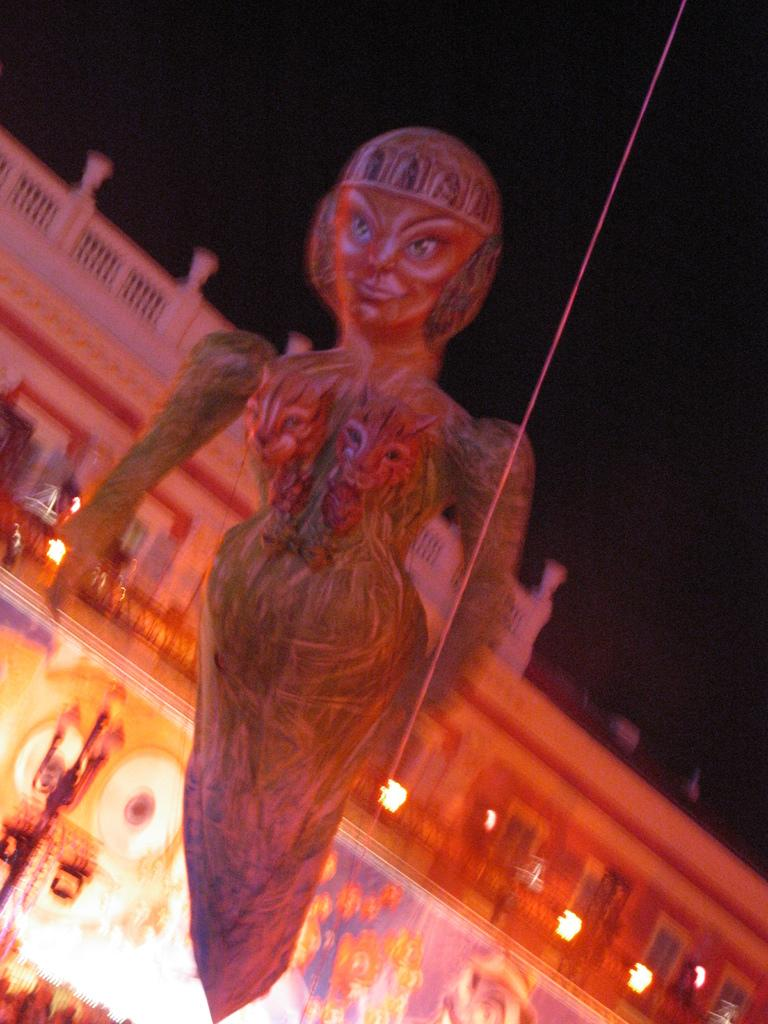What is the main subject in the center of the image? There is a doll in the center of the image. How are the walls of the house depicted in the image? The house has painted walls. Can you describe the object located in the bottom left corner of the image? Unfortunately, the provided facts do not give enough information to describe the object in the bottom left corner of the image. What type of instrument is being played by the doll's toe in the image? There is no instrument or toe present in the image; it only features a doll in the center. 